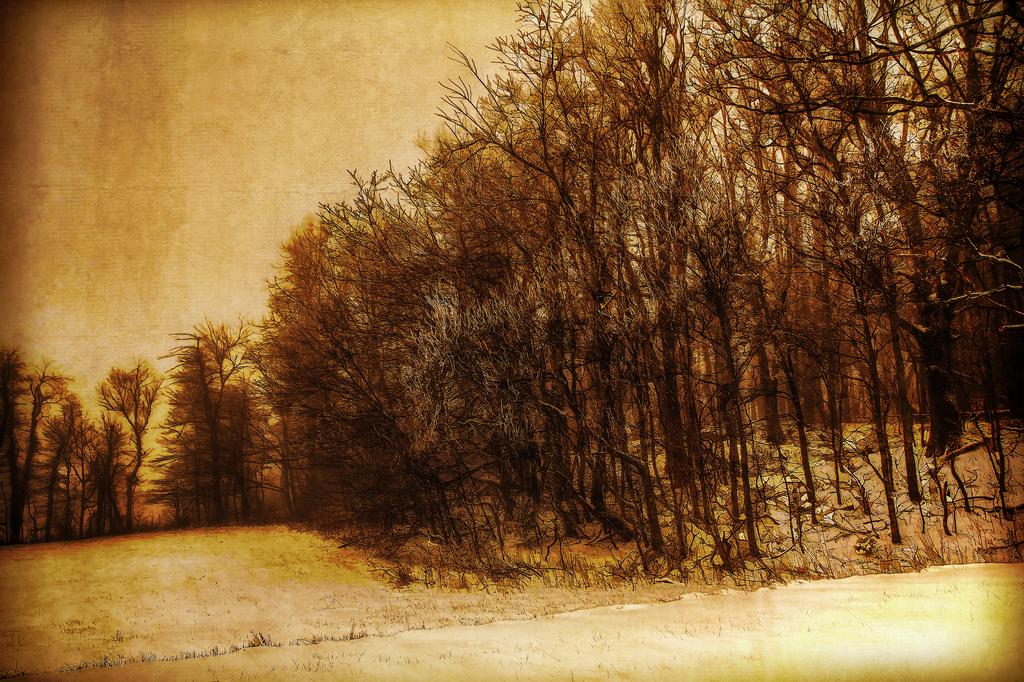What type of natural vegetation is visible in the image? There are trees in the image. What part of the natural environment is visible in the image? The ground and the sky are visible in the image. What is the medium of the image? The image is a painting. Where is the monkey sitting on a cushion in the image? There is no monkey or cushion present in the image; it features trees, the ground, and the sky. 